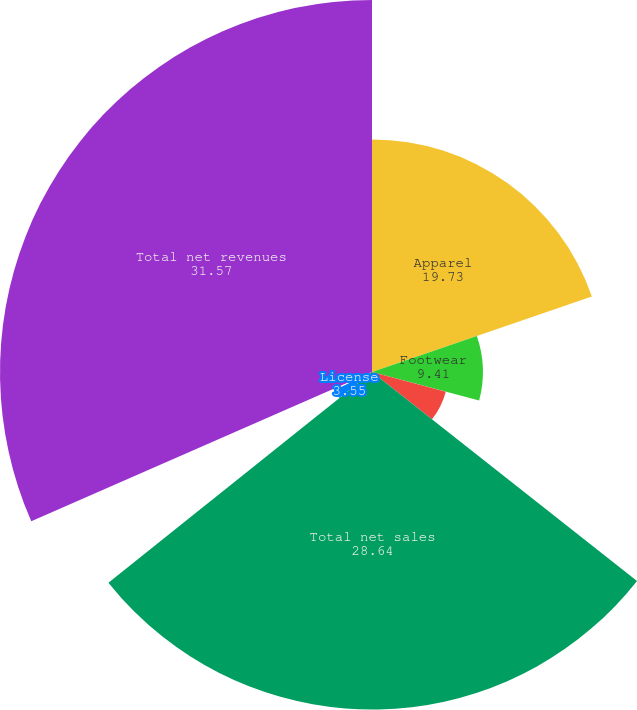<chart> <loc_0><loc_0><loc_500><loc_500><pie_chart><fcel>Apparel<fcel>Footwear<fcel>Accessories<fcel>Total net sales<fcel>License<fcel>Connected Fitness<fcel>Total net revenues<nl><fcel>19.73%<fcel>9.41%<fcel>6.48%<fcel>28.64%<fcel>3.55%<fcel>0.61%<fcel>31.57%<nl></chart> 